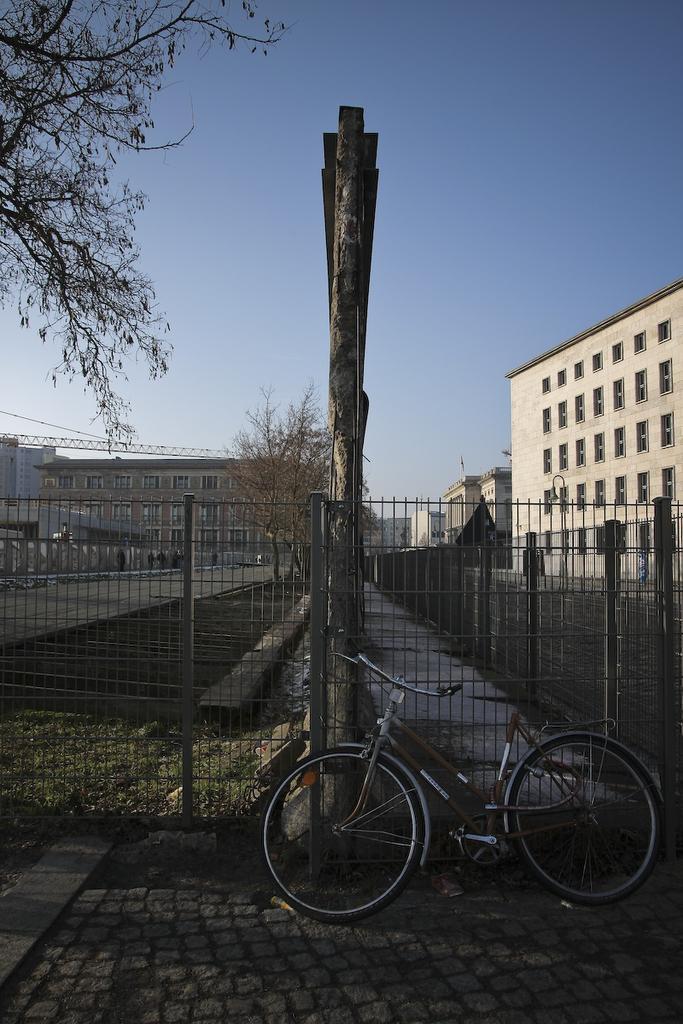Can you describe this image briefly? In this image I can see the ground, a bicycle, a metal fencing, a wooden pole and few trees. In the background I can see few buildings and the sky. 